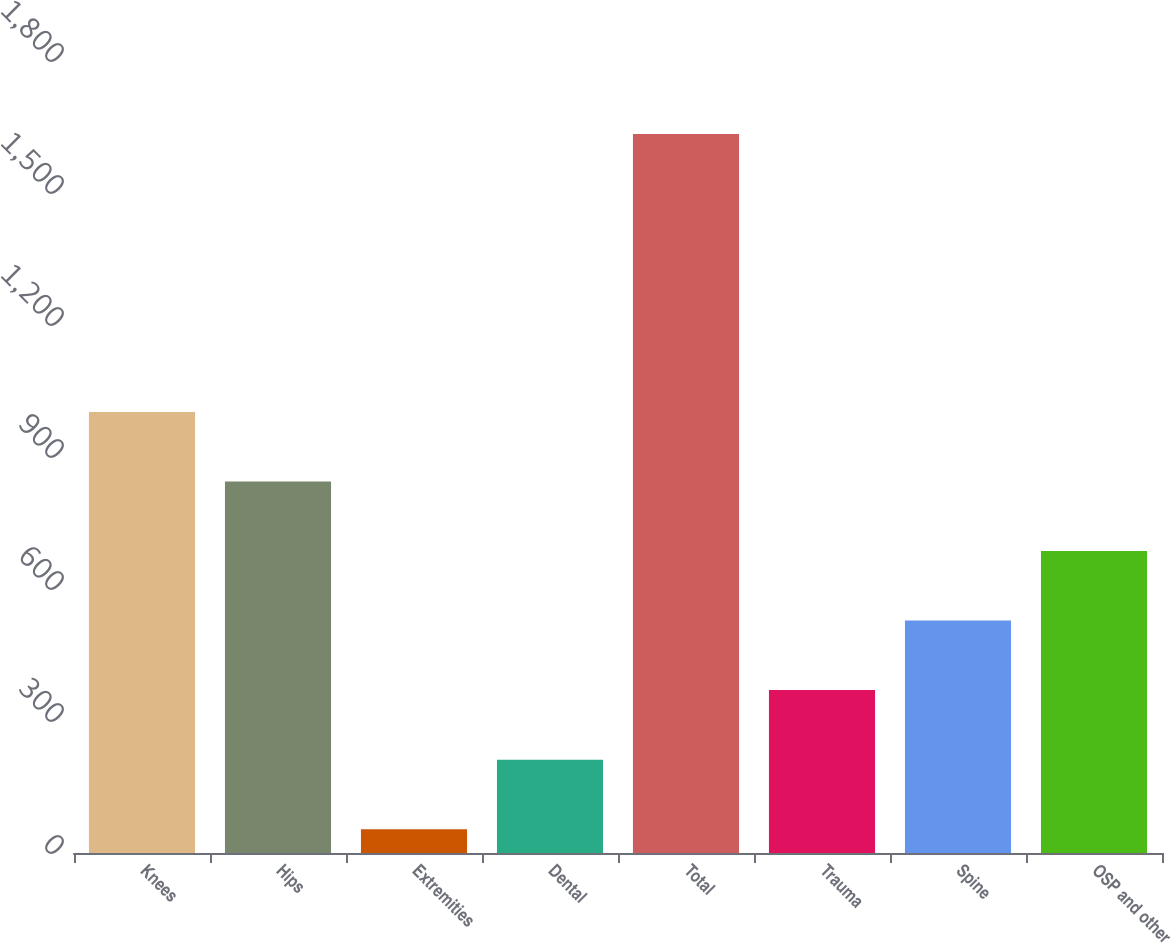Convert chart. <chart><loc_0><loc_0><loc_500><loc_500><bar_chart><fcel>Knees<fcel>Hips<fcel>Extremities<fcel>Dental<fcel>Total<fcel>Trauma<fcel>Spine<fcel>OSP and other<nl><fcel>1002.2<fcel>844.2<fcel>54.2<fcel>212.2<fcel>1634.2<fcel>370.2<fcel>528.2<fcel>686.2<nl></chart> 